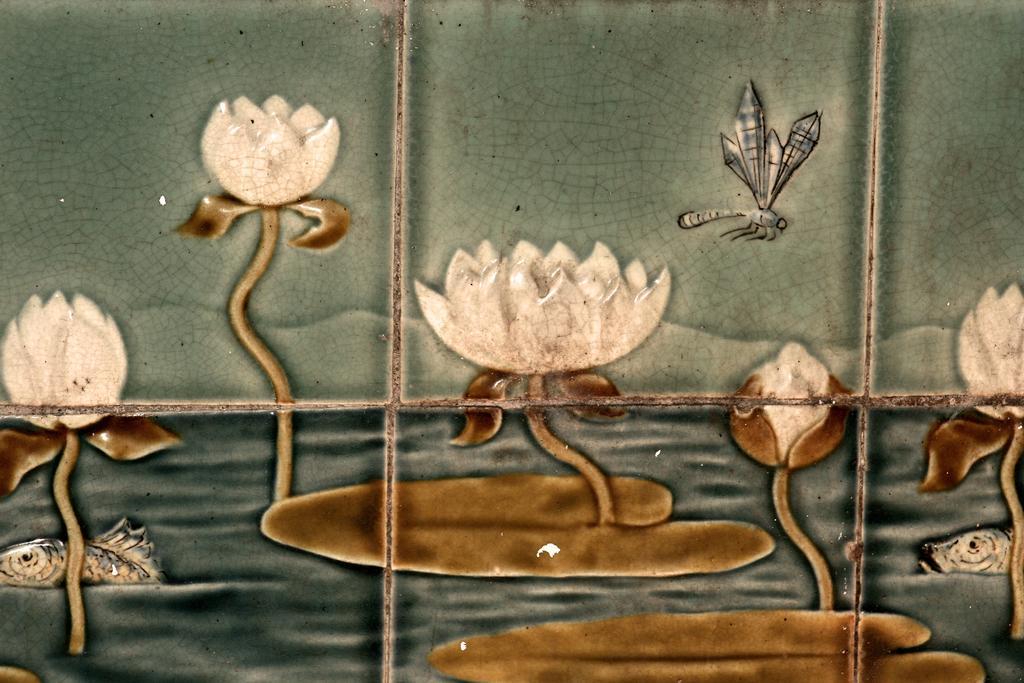How would you summarize this image in a sentence or two? In this image we can see painting of lotus flowers and leaves floating on the water. Also there are fishes. And we can see dragonfly. 